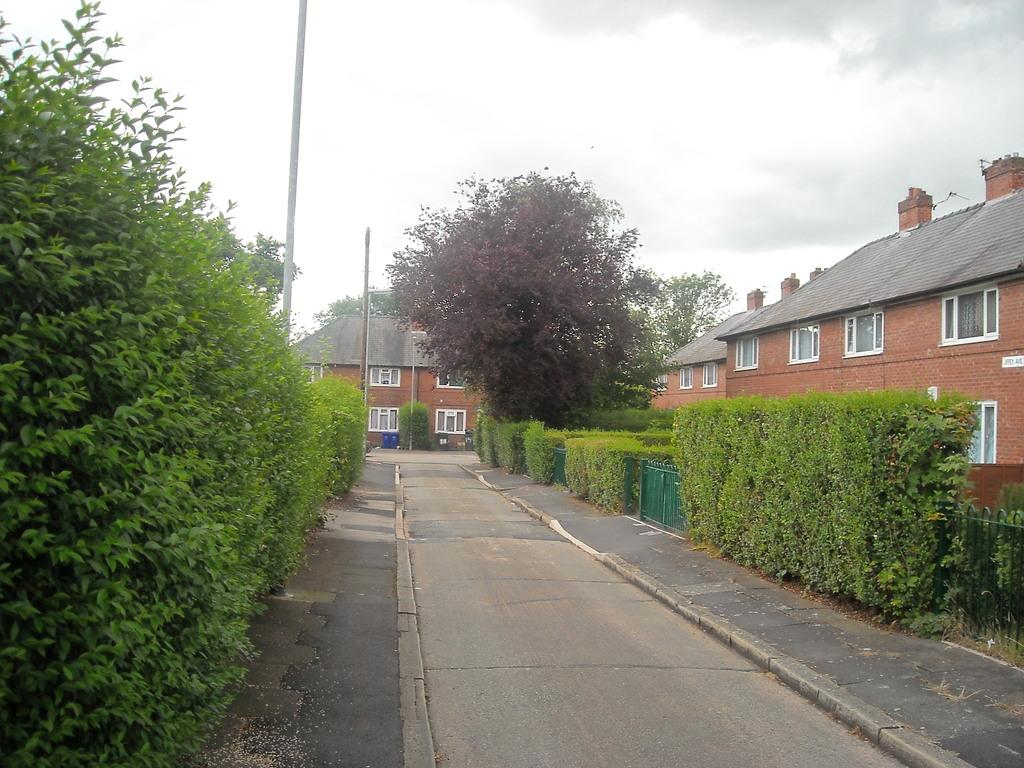What type of vegetation can be seen on both sides of the path in the image? There are trees and plants on both sides of the path in the image. What structures can be seen in the image? There are buildings visible in the image. What object can be seen in the image that is typically used for supporting or holding something? There is a pole in the image. What is the condition of the sky in the image? The sky is cloudy in the image. What type of relation does the pole have with the trees in the image? The pole does not have a relation with the trees in the image, as it is a separate object. Who is the representative of the plants in the image? There is no representative of the plants in the image, as they are inanimate objects. 